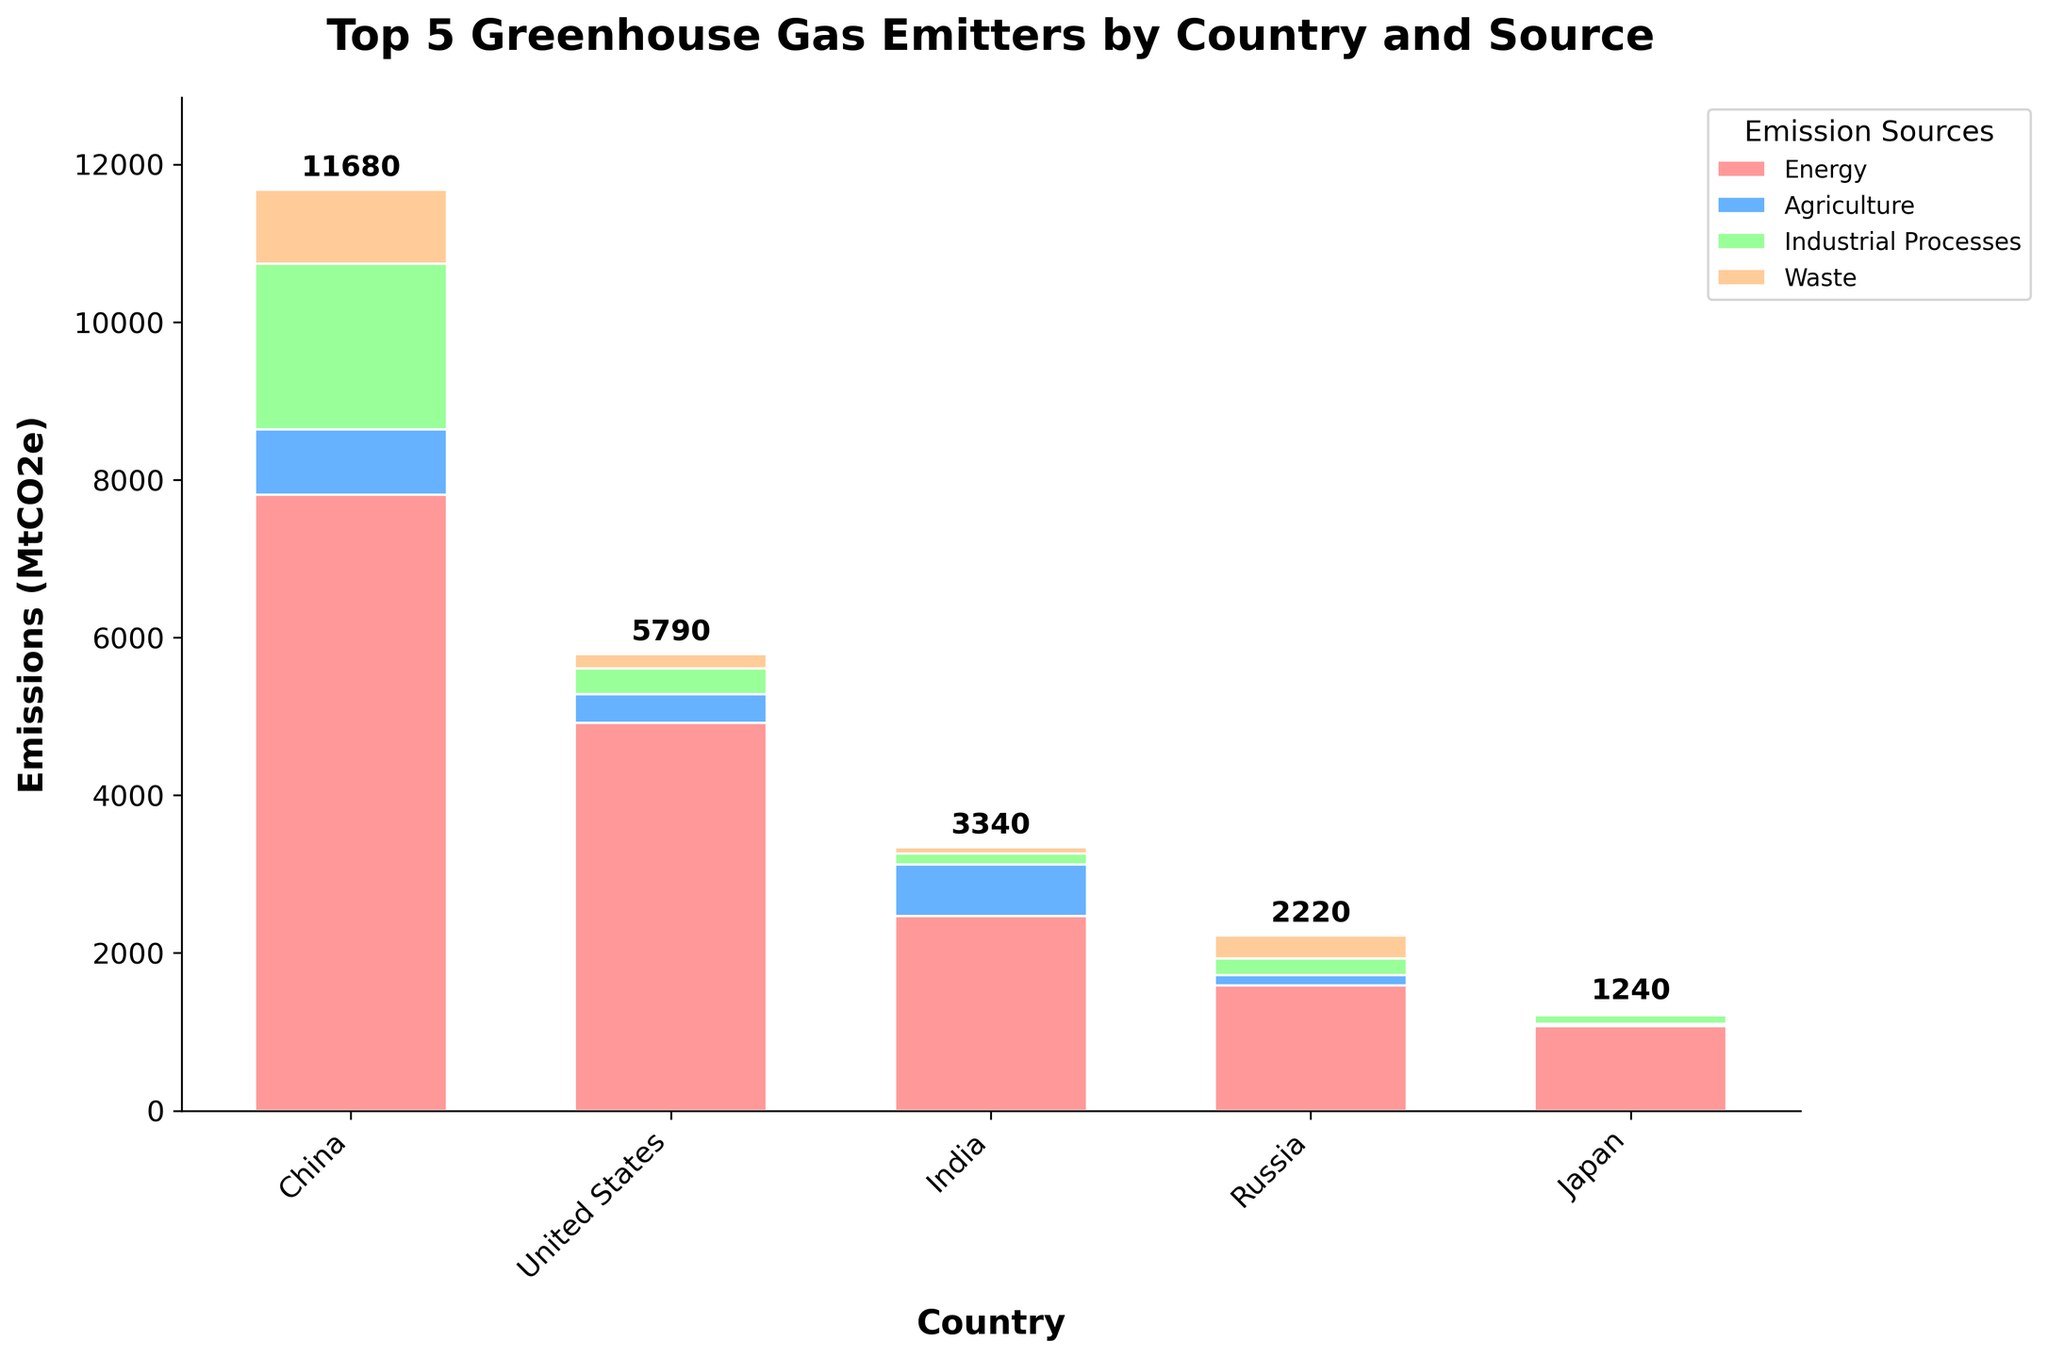Which country has the highest total greenhouse gas emissions? By looking at the height of the stacked bars and the numerical labels on top of each bar, we can see that China has the highest total emissions at 11680 MtCO2e.
Answer: China Which country has the least emissions from agriculture? By comparing the heights of the green segments of each bar, we can see that Japan has the smallest green segment, representing 30 MtCO2e in emissions from agriculture.
Answer: Japan How much greater are China's industrial process emissions than India's? The value for China’s industrial process emissions is 2100 MtCO2e, and for India, it’s 140 MtCO2e. The difference is 2100 - 140 = 1960 MtCO2e.
Answer: 1960 MtCO2e Which two countries have the closest total emissions, and what are their emissions? By visually comparing the height of the stacked bars and their numerical labels, Russia and Japan have the closest total emissions at 2220 MtCO2e and 1240 MtCO2e, respectively. The difference is 2220 - 1240 = 980 MtCO2e, which is smaller compared to other countries.
Answer: Russia and Japan What is the combined total of greenhouse gas emissions from waste for all five countries? Adding the emissions attributed to waste for all countries: 940 (China) + 180 (USA) + 80 (India) + 290 (Russia) + 30 (Japan) = 1520 MtCO2e.
Answer: 1520 MtCO2e Which country has the largest contribution of energy-related emissions to its total emissions? To find the country with the largest energy-related proportion, examine the relative height of the blue segment compared to the total height of each bar. The USA has the largest proportion since the blue segment (4920 MtCO2e) is significantly high relative to its total emissions (5790 MtCO2e). Calculation: 4920 / 5790 ≈ 0.85 (85%).
Answer: United States What is the total greenhouse gas emissions from industrial processes for all countries except China? Sum the industrial process emissions for countries other than China: 330 (USA) + 140 (India) + 210 (Russia) + 110 (Japan) = 790 MtCO2e.
Answer: 790 MtCO2e How does the total emission from agriculture in Russia compare to Japan’s total emissions from all sources? Russia’s agriculture emissions are 130 MtCO2e and Japan’s total emissions are 1240 MtCO2e. Russia's emissions from agriculture are much less than Japan’s total emissions.
Answer: Russia's agriculture < Japan's total 